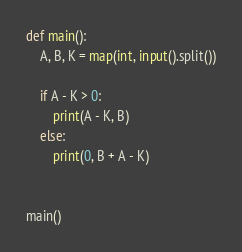Convert code to text. <code><loc_0><loc_0><loc_500><loc_500><_Python_>def main():
    A, B, K = map(int, input().split())

    if A - K > 0:
        print(A - K, B)
    else:
        print(0, B + A - K)


main()
</code> 